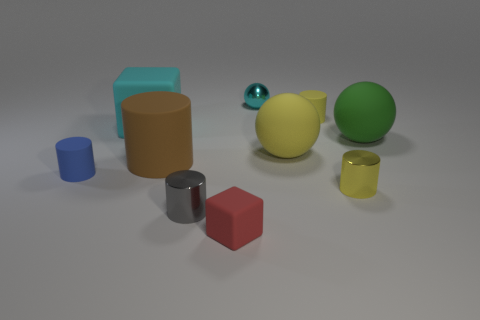Subtract all big matte cylinders. How many cylinders are left? 4 Subtract all blue cylinders. How many cylinders are left? 4 Subtract all red cylinders. Subtract all cyan blocks. How many cylinders are left? 5 Subtract all cubes. How many objects are left? 8 Add 5 small blocks. How many small blocks are left? 6 Add 5 cyan shiny balls. How many cyan shiny balls exist? 6 Subtract 1 red blocks. How many objects are left? 9 Subtract all red objects. Subtract all large brown cylinders. How many objects are left? 8 